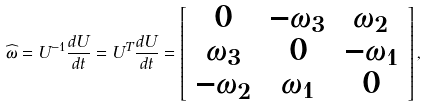Convert formula to latex. <formula><loc_0><loc_0><loc_500><loc_500>\widehat { \omega } = U ^ { - 1 } \frac { d U } { d t } = U ^ { T } \frac { d U } { d t } = \left [ \begin{array} { c c c } 0 & - \omega _ { 3 } & \omega _ { 2 } \\ \omega _ { 3 } & 0 & - \omega _ { 1 } \\ - \omega _ { 2 } & \omega _ { 1 } & 0 \end{array} \right ] ,</formula> 